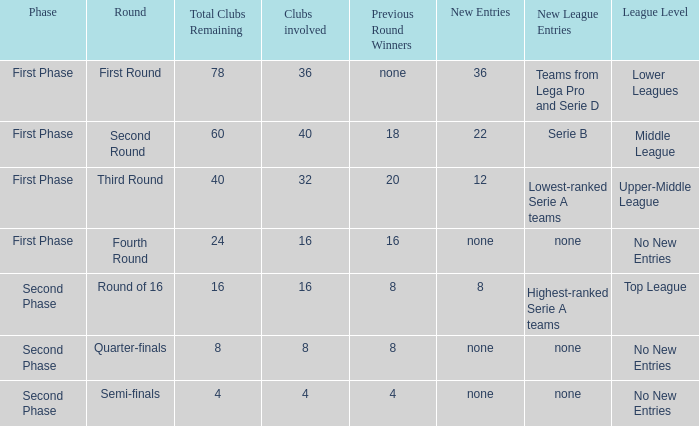Considering 8 new clubs joined this round, what is the current total of clubs still in the competition? 1.0. 